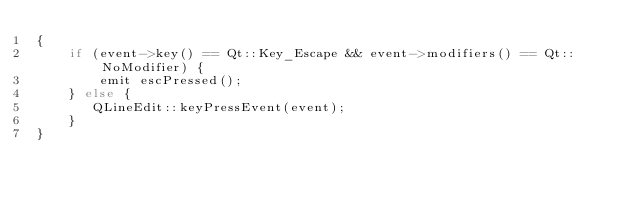Convert code to text. <code><loc_0><loc_0><loc_500><loc_500><_C++_>{
    if (event->key() == Qt::Key_Escape && event->modifiers() == Qt::NoModifier) {
        emit escPressed();
    } else {
       QLineEdit::keyPressEvent(event);
    }
}
</code> 